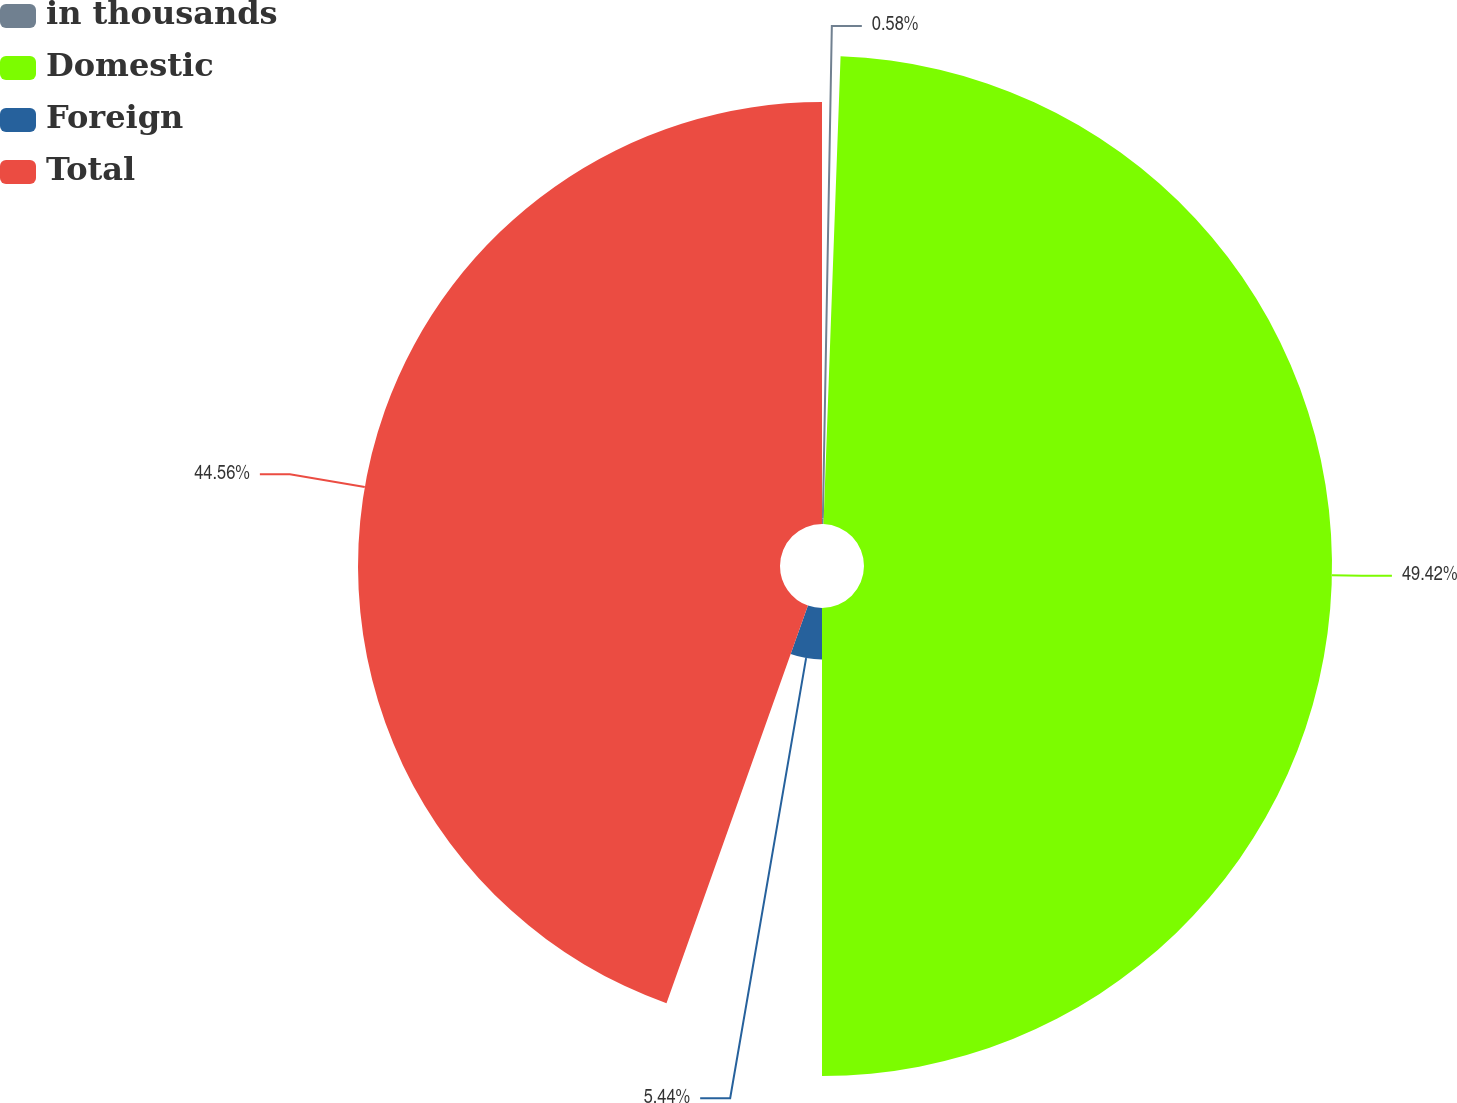Convert chart to OTSL. <chart><loc_0><loc_0><loc_500><loc_500><pie_chart><fcel>in thousands<fcel>Domestic<fcel>Foreign<fcel>Total<nl><fcel>0.58%<fcel>49.42%<fcel>5.44%<fcel>44.56%<nl></chart> 